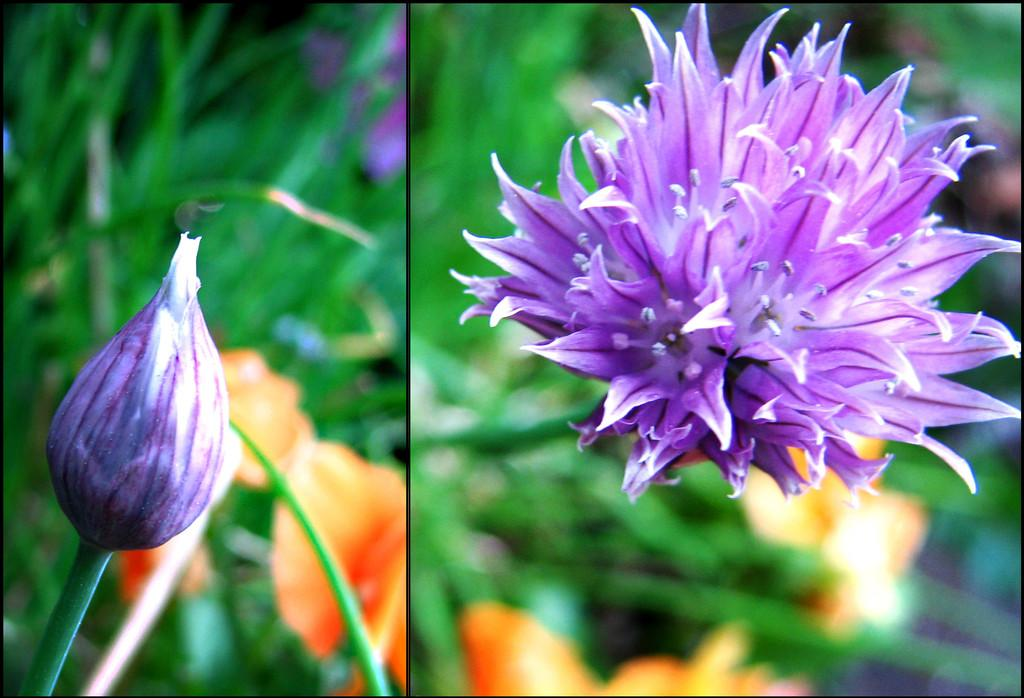What type of plant can be seen on the right side of the image? There is a flower visible on the right side of the image. What part of the flower is visible on the left side of the image? There is a bud and stem on the left side of the image. What type of vegetation is present in the image besides the flower? There is grass in the image. What color are the flowers in the image? There are red color flowers in the image. Where is the pail located in the image? There is no pail present in the image. What type of fruit is the cub eating in the image? There is no cub or fruit present in the image. 